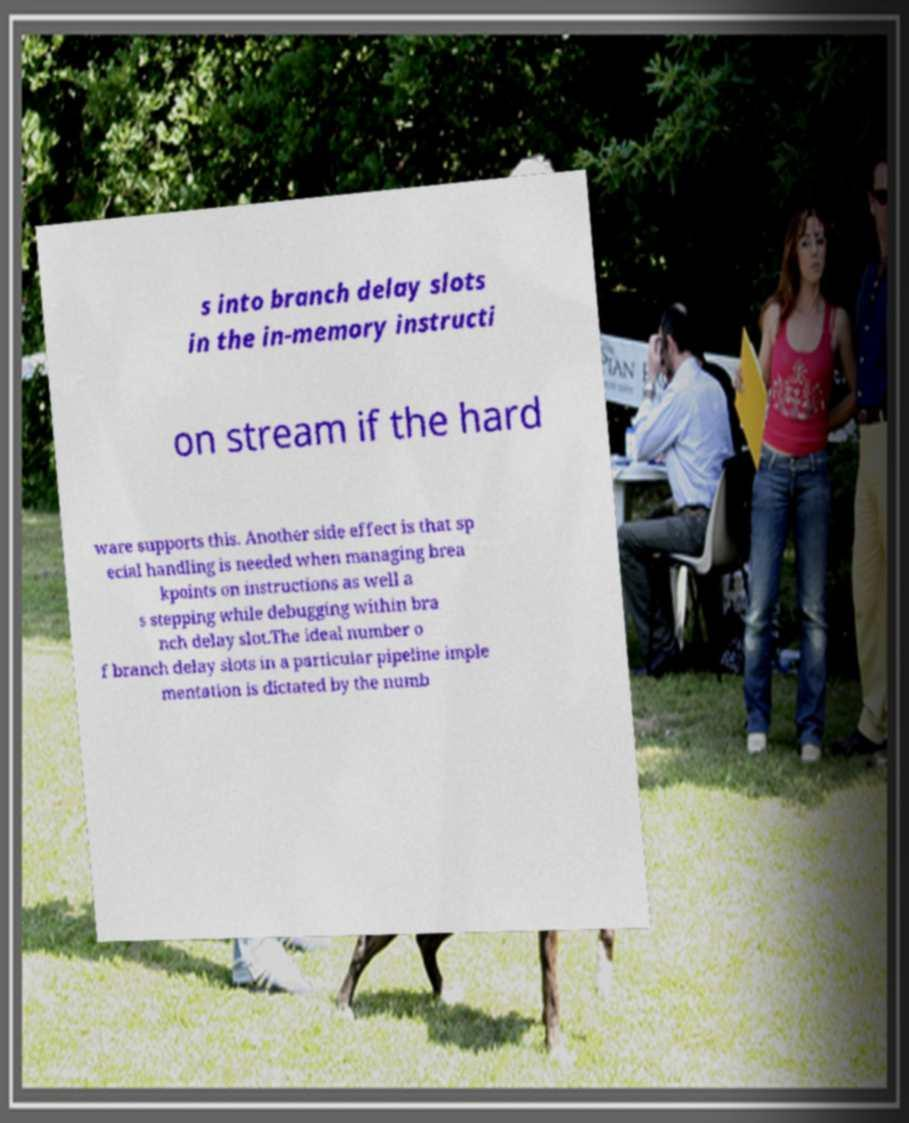I need the written content from this picture converted into text. Can you do that? s into branch delay slots in the in-memory instructi on stream if the hard ware supports this. Another side effect is that sp ecial handling is needed when managing brea kpoints on instructions as well a s stepping while debugging within bra nch delay slot.The ideal number o f branch delay slots in a particular pipeline imple mentation is dictated by the numb 